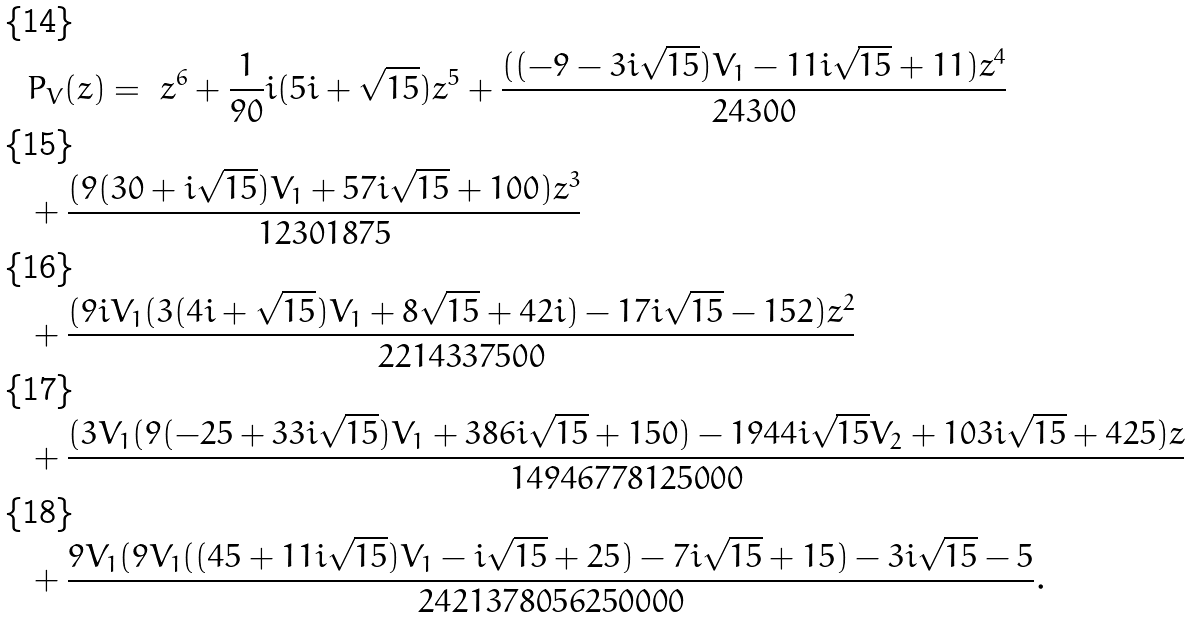<formula> <loc_0><loc_0><loc_500><loc_500>& P _ { V } ( z ) = \ z ^ { 6 } + \frac { 1 } { 9 0 } i ( 5 i + \sqrt { 1 5 } ) z ^ { 5 } + \frac { ( ( - 9 - 3 i \sqrt { 1 5 } ) V _ { 1 } - 1 1 i \sqrt { 1 5 } + 1 1 ) z ^ { 4 } } { 2 4 3 0 0 } \\ & + \frac { ( 9 ( 3 0 + i \sqrt { 1 5 } ) V _ { 1 } + 5 7 i \sqrt { 1 5 } + 1 0 0 ) z ^ { 3 } } { 1 2 3 0 1 8 7 5 } \\ & + \frac { ( 9 i V _ { 1 } ( 3 ( 4 i + \sqrt { 1 5 } ) V _ { 1 } + 8 \sqrt { 1 5 } + 4 2 i ) - 1 7 i \sqrt { 1 5 } - 1 5 2 ) z ^ { 2 } } { 2 2 1 4 3 3 7 5 0 0 } \\ & + \frac { ( 3 V _ { 1 } ( 9 ( - 2 5 + 3 3 i \sqrt { 1 5 } ) V _ { 1 } + 3 8 6 i \sqrt { 1 5 } + 1 5 0 ) - 1 9 4 4 i \sqrt { 1 5 } V _ { 2 } + 1 0 3 i \sqrt { 1 5 } + 4 2 5 ) z } { 1 4 9 4 6 7 7 8 1 2 5 0 0 0 } \\ & + \frac { 9 V _ { 1 } ( 9 V _ { 1 } ( ( 4 5 + 1 1 i \sqrt { 1 5 } ) V _ { 1 } - i \sqrt { 1 5 } + 2 5 ) - 7 i \sqrt { 1 5 } + 1 5 ) - 3 i \sqrt { 1 5 } - 5 } { 2 4 2 1 3 7 8 0 5 6 2 5 0 0 0 0 } .</formula> 